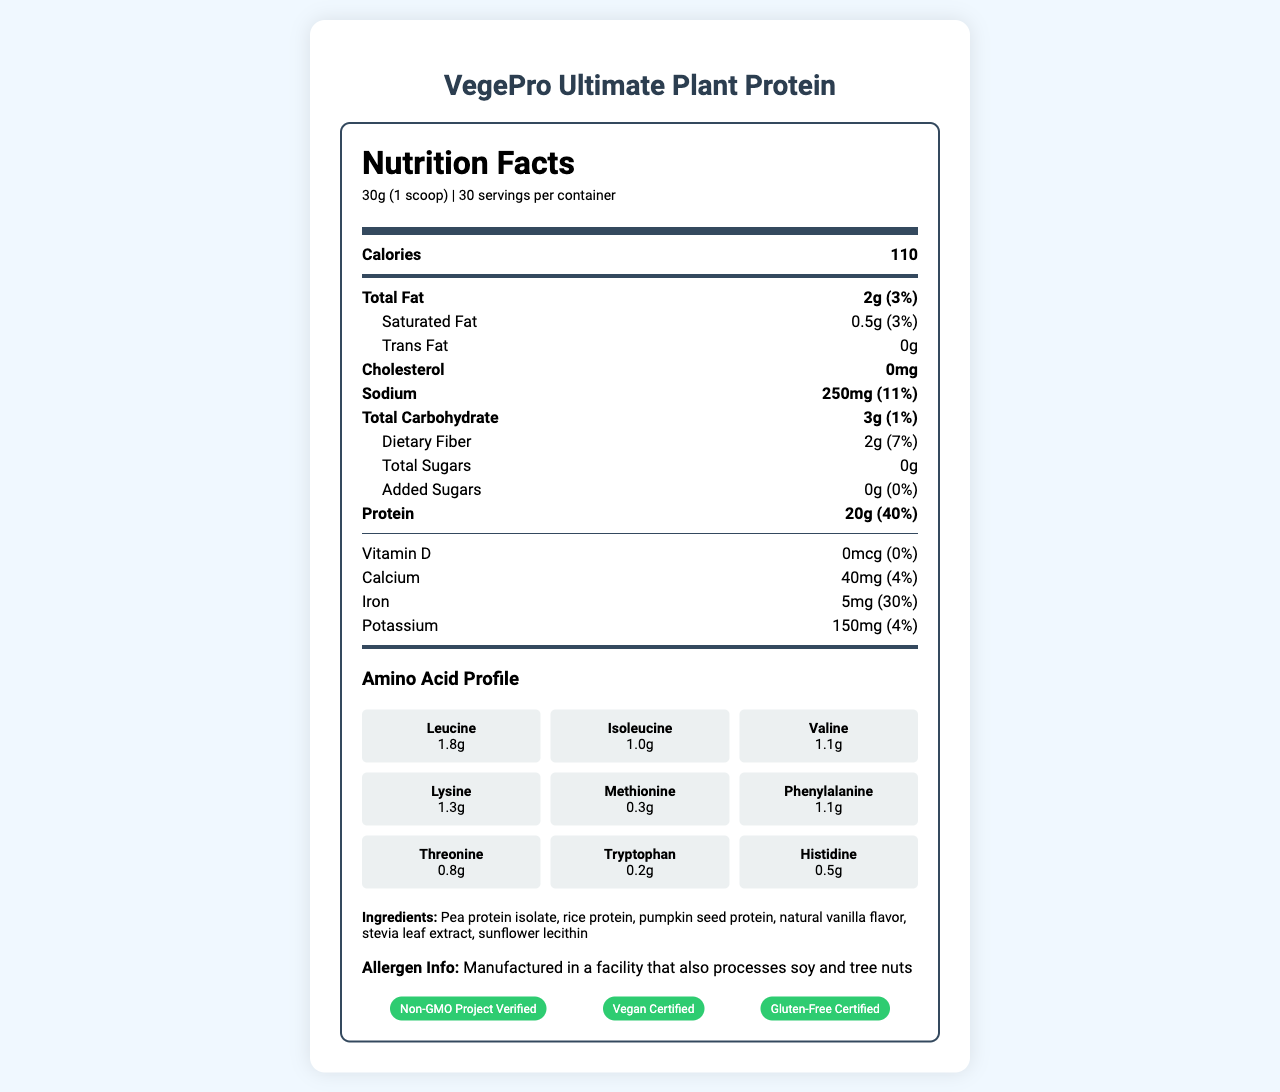what is the product name? The product name is clearly mentioned at the top of the document.
Answer: VegePro Ultimate Plant Protein what is the serving size? The serving size is listed right under the Nutrition Facts header in the document.
Answer: 30g (1 scoop) how many calories are in one serving? The calories per serving are shown prominently in the Nutrition Facts section.
Answer: 110 which certification does this product have? A. USDA Organic B. Gluten-Free Certified C. Keto Certified The document lists "Gluten-Free Certified" as one of the certifications.
Answer: B how much protein is in each serving of VegePro Ultimate Plant Protein? The protein content per serving is detailed in the Nutrition Facts section.
Answer: 20g does the product contain any cholesterol? The Nutrition Facts label clearly indicates that the amount of cholesterol is 0mg.
Answer: No which amino acid is present in the highest quantity? A. Leucine B. Tryptophan C. Methionine The amino acid profile shows Leucine with 1.8g, which is the highest among the listed amino acids.
Answer: A is there any added sugar in this protein powder? The document states that the amount of added sugars is 0g.
Answer: No what is the percentage Daily Value of iron? The percentage Daily Value of iron is listed as 30% in the Nutrition Facts section.
Answer: 30% what is the main claim of VegePro Ultimate Plant Protein? One of the prominent marketing claims is that it has a complete amino acid profile.
Answer: It has a complete amino acid profile. summarize the main nutrition and marketing benefits of VegePro Ultimate Plant Protein. The product offers significant protein content with a complete amino acid profile, making it beneficial for muscle recovery. It is certified and marketed as vegan, gluten-free, non-GMO, and environmentally friendly.
Answer: VegePro Ultimate Plant Protein provides 20g of protein per serving with a complete amino acid profile, low fat, and zero added sugars. It is certified vegan, gluten-free, and non-GMO, and it supports muscle recovery and is easy to digest. what is the product's sodium content per serving? The document lists the sodium content per serving as 250mg.
Answer: 250mg how many servings are there in each container? The number of servings per container is specified as 30.
Answer: 30 which certifications are associated with VegePro Ultimate Plant Protein? These certifications are listed under the certifications section of the document.
Answer: Non-GMO Project Verified, Vegan Certified, Gluten-Free Certified what are the allergens mentioned for the product? The allergen information specifies that it is manufactured in a facility that processes soy and tree nuts.
Answer: Manufactured in a facility that also processes soy and tree nuts what flavor variant does this product have? The document does not specify flavor variants; it only mentions natural vanilla flavor.
Answer: Not enough information is iron content high compared to calcium and potassium? The iron content has a Daily Value percentage of 30%, which is higher compared to 4% for calcium and 4% for potassium.
Answer: Yes 